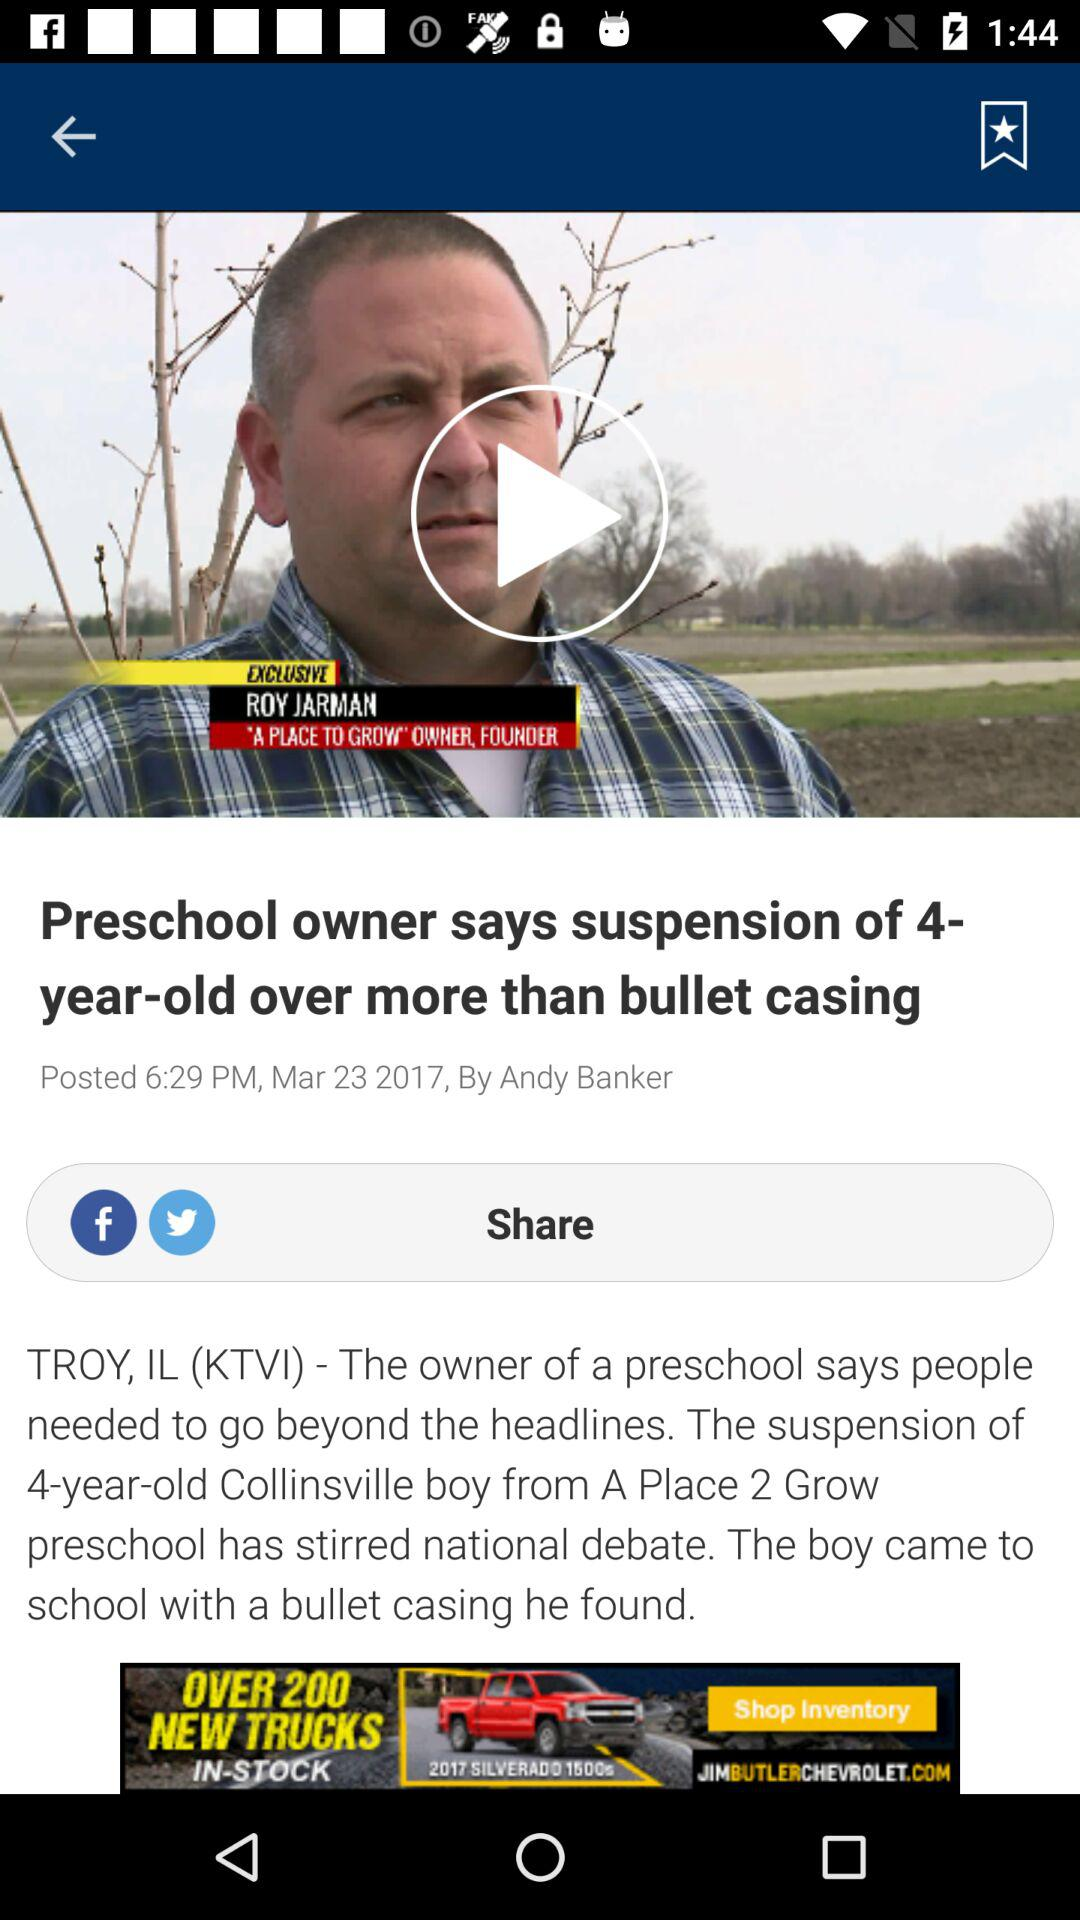Who's the author of the article? The author of the article is Andy Banker. 